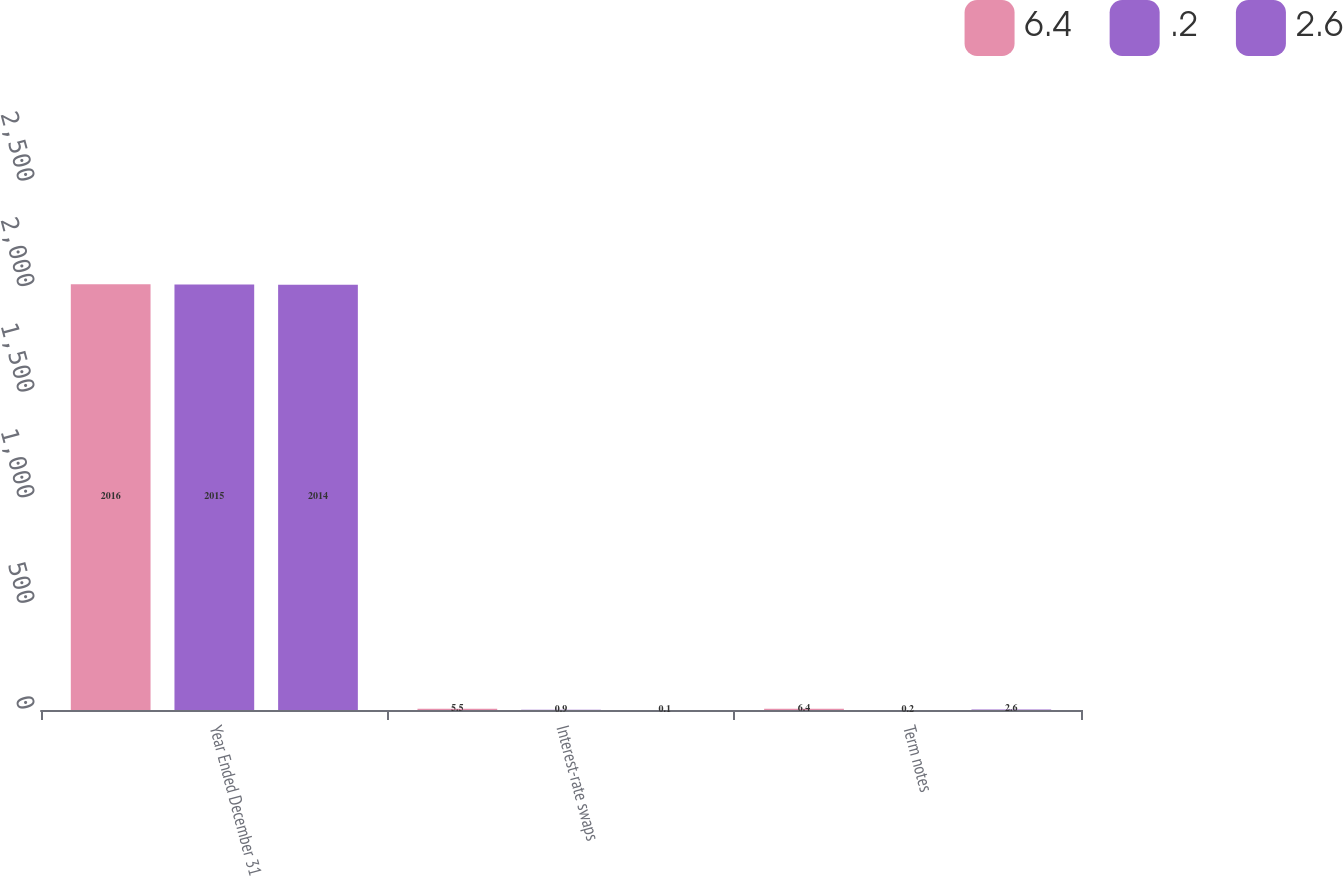Convert chart to OTSL. <chart><loc_0><loc_0><loc_500><loc_500><stacked_bar_chart><ecel><fcel>Year Ended December 31<fcel>Interest-rate swaps<fcel>Term notes<nl><fcel>6.4<fcel>2016<fcel>5.5<fcel>6.4<nl><fcel>0.2<fcel>2015<fcel>0.9<fcel>0.2<nl><fcel>2.6<fcel>2014<fcel>0.1<fcel>2.6<nl></chart> 